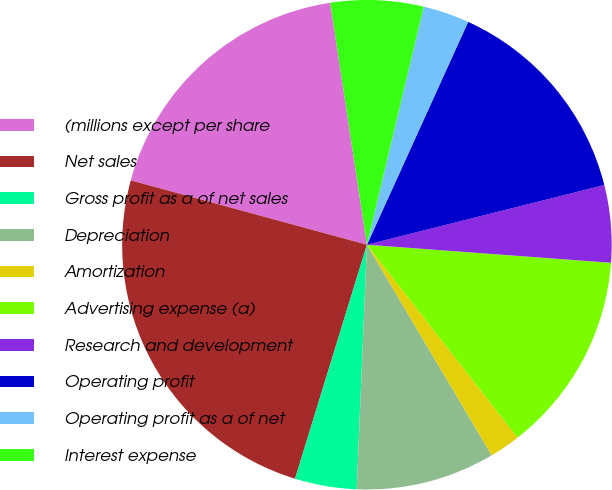Convert chart. <chart><loc_0><loc_0><loc_500><loc_500><pie_chart><fcel>(millions except per share<fcel>Net sales<fcel>Gross profit as a of net sales<fcel>Depreciation<fcel>Amortization<fcel>Advertising expense (a)<fcel>Research and development<fcel>Operating profit<fcel>Operating profit as a of net<fcel>Interest expense<nl><fcel>18.37%<fcel>24.49%<fcel>4.08%<fcel>9.18%<fcel>2.04%<fcel>13.27%<fcel>5.1%<fcel>14.29%<fcel>3.06%<fcel>6.12%<nl></chart> 